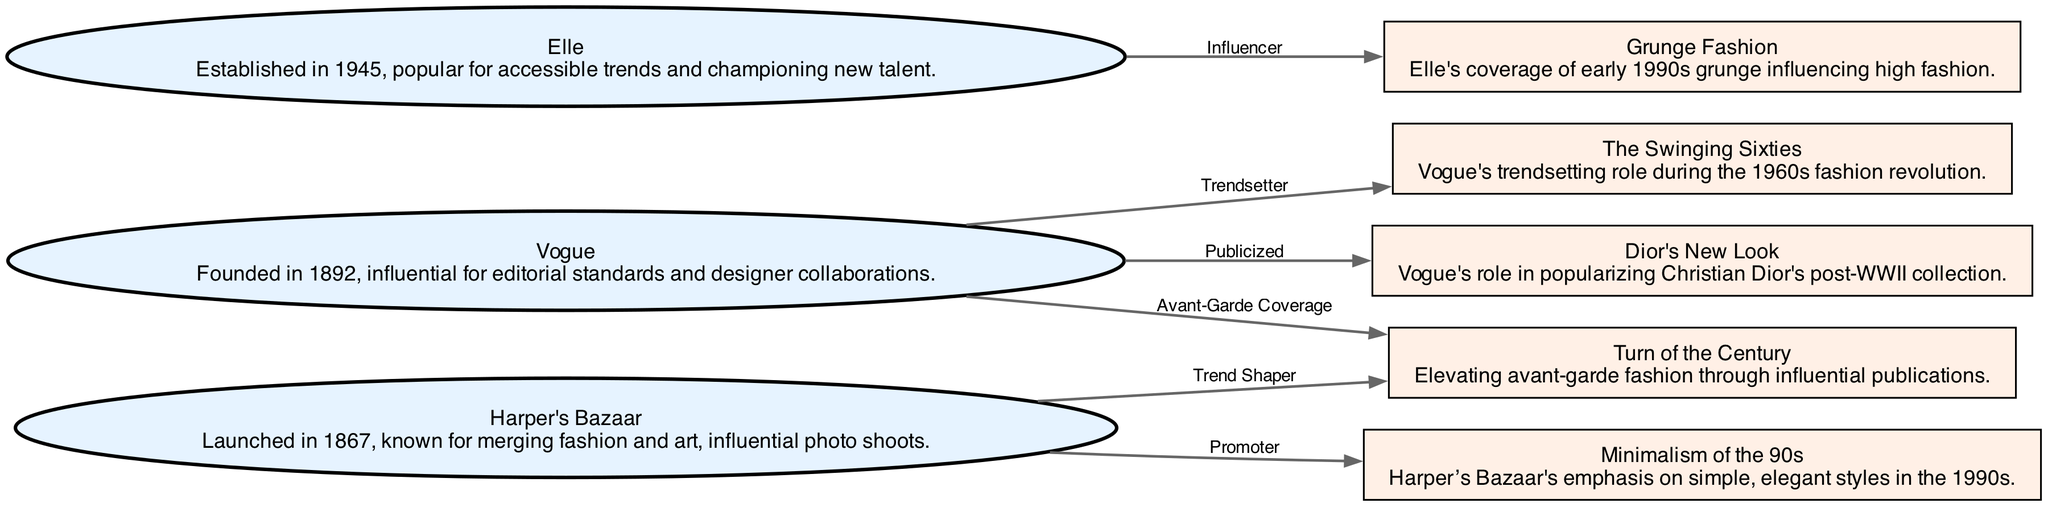What is the total number of nodes in the diagram? The diagram has 8 nodes: Vogue, Harper's Bazaar, Elle, The Swinging Sixties, Minimalism of the 90s, Dior's New Look, Grunge Fashion, and End of Century Turn.
Answer: 8 Which magazine is associated with the trend "Grunge Fashion"? The edge from "Elle" to "Grunge Fashion" shows that Elle is the influencer of that trend.
Answer: Elle What relationship does Vogue have with "Dior's New Look"? The diagram indicates that Vogue publicized "Dior's New Look," hence the relationship is 'Publicized'.
Answer: Publicized Who promoted the "Minimalism of the 90s" trend? The diagram reveals that "Harper's Bazaar" promoted this trend, thus establishing the magazine's influence during that decade.
Answer: Harper's Bazaar Which magazine is a trendsetter during "The Swinging Sixties"? According to the diagram, Vogue is marked as the trendsetter during this period, emphasizing its pivotal role in fashion.
Answer: Vogue What is the label for the relationship between Harper's Bazaar and "End of Century Turn"? The edge connecting Harper's Bazaar to "End of Century Turn" is labeled 'Trend Shaper'. Hence, this specifies the nature of their connection.
Answer: Trend Shaper Which node has been influenced by Elle according to the diagram? The diagram shows that Elle influenced "Grunge Fashion," establishing the impact of its coverage on this specific trend.
Answer: Grunge Fashion What role did Vogue play in "End of Century Turn"? The diagram indicates that Vogue provided 'Avant-Garde Coverage', signifying its influential position in elevating innovative designs.
Answer: Avant-Garde Coverage 